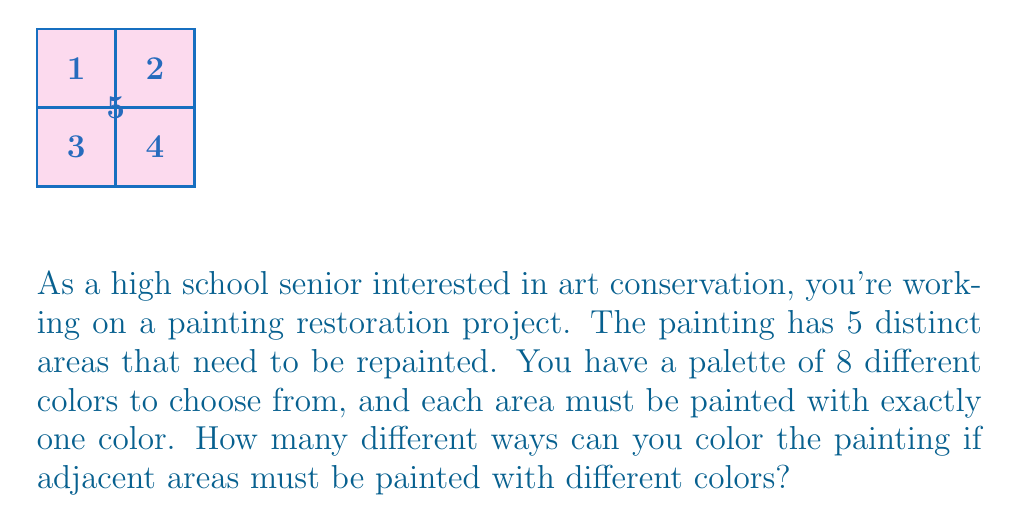What is the answer to this math problem? Let's approach this step-by-step using the principle of multiplication and the concept of coloring adjacent regions differently:

1) First, let's consider the center area (5). We have 8 choices for this area.

2) For each of the four surrounding areas (1, 2, 3, 4), we can't use the color used in the center. So for each of these, we have 7 choices.

3) However, areas 1 and 2 are adjacent, as are areas 3 and 4. This means we need to ensure these pairs have different colors.

4) Let's count systematically:
   - Choose a color for area 5: 8 choices
   - Choose a color for area 1: 7 choices (can't use area 5's color)
   - Choose a color for area 2: 6 choices (can't use area 5's or area 1's color)
   - Choose a color for area 3: 6 choices (can't use area 5's color, but areas 1 and 2's colors are available)
   - Choose a color for area 4: 5 choices (can't use area 5's or area 3's color)

5) By the multiplication principle, the total number of ways to color the painting is:

   $$ 8 \times 7 \times 6 \times 6 \times 5 = 10,080 $$

Therefore, there are 10,080 different ways to color the painting under these constraints.
Answer: 10,080 